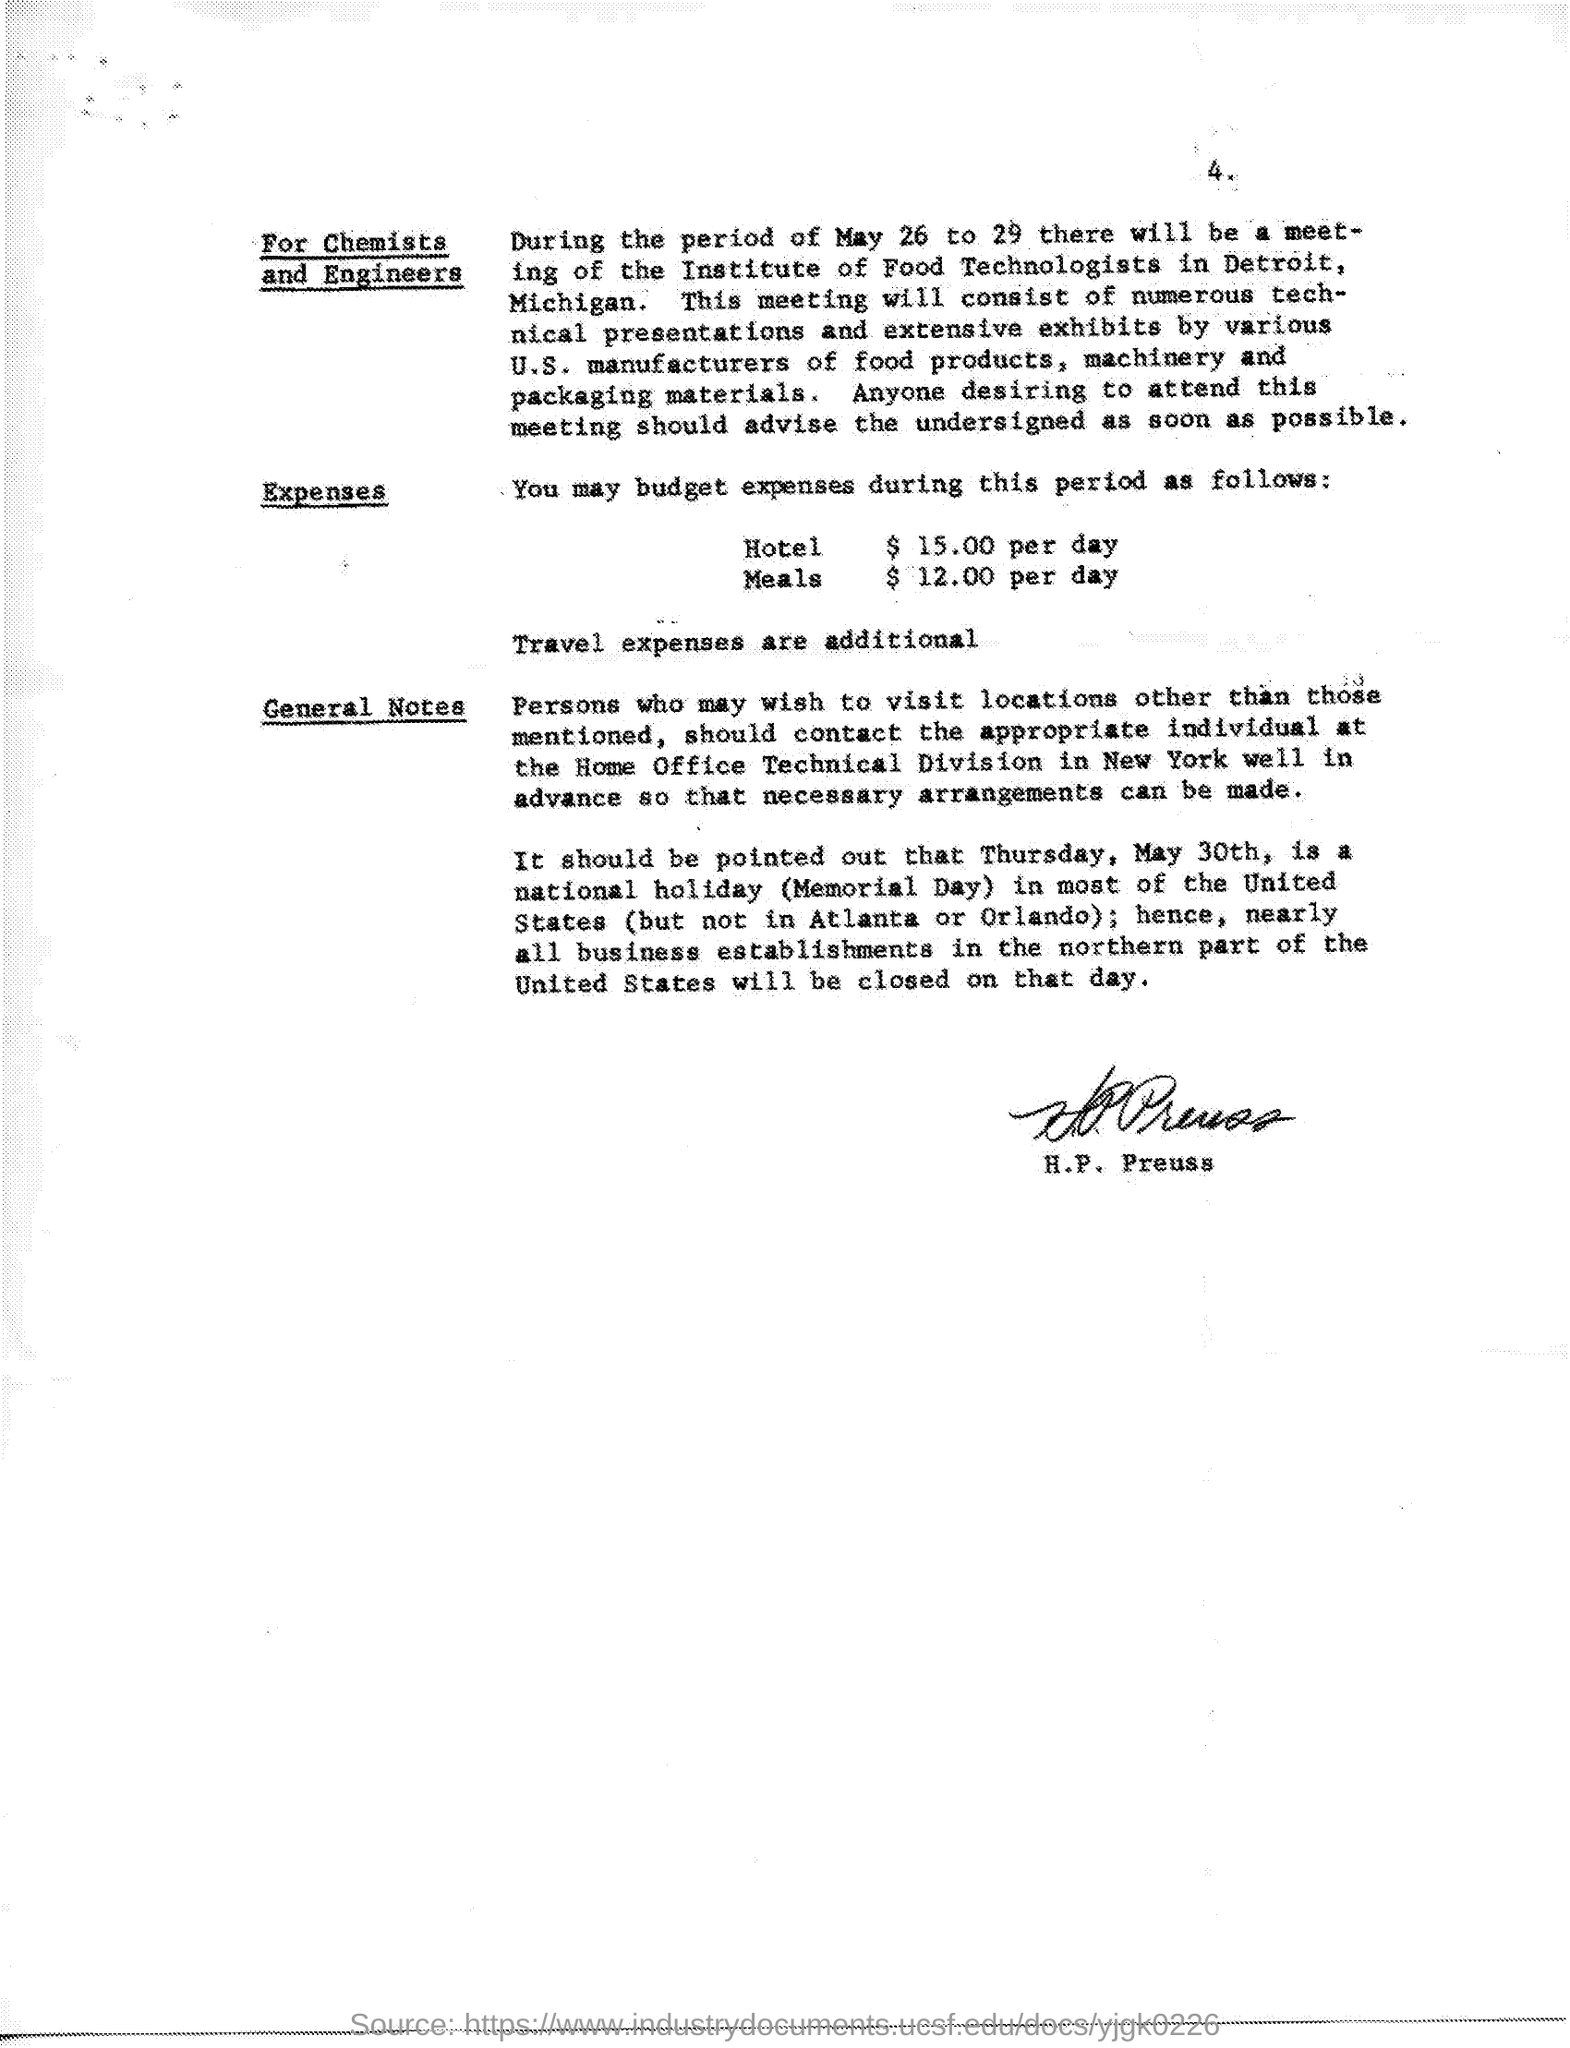What is the hotel expense?
Your response must be concise. $ 15.00 per day. When is the meeting for chemists and engineers
Provide a succinct answer. May 26 to 29. 